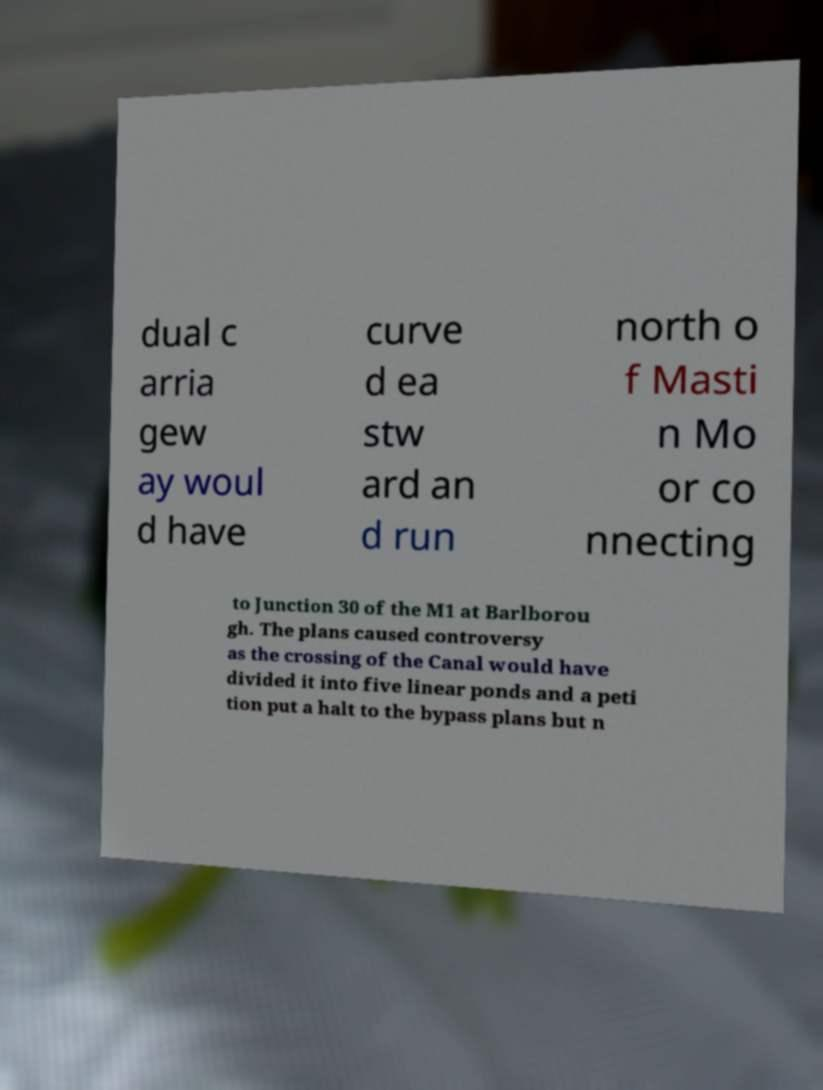Could you extract and type out the text from this image? dual c arria gew ay woul d have curve d ea stw ard an d run north o f Masti n Mo or co nnecting to Junction 30 of the M1 at Barlborou gh. The plans caused controversy as the crossing of the Canal would have divided it into five linear ponds and a peti tion put a halt to the bypass plans but n 